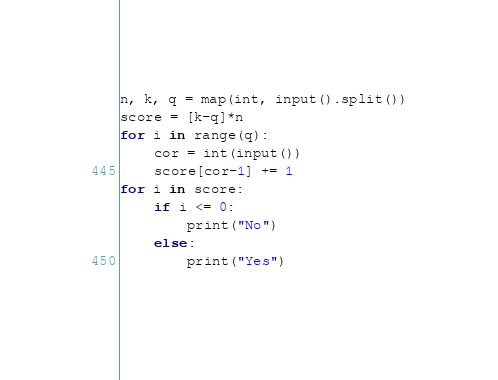Convert code to text. <code><loc_0><loc_0><loc_500><loc_500><_Python_>n, k, q = map(int, input().split())
score = [k-q]*n
for i in range(q):
    cor = int(input())
    score[cor-1] += 1
for i in score:
    if i <= 0:
        print("No")
    else:
        print("Yes")
		</code> 